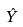<formula> <loc_0><loc_0><loc_500><loc_500>\hat { Y }</formula> 